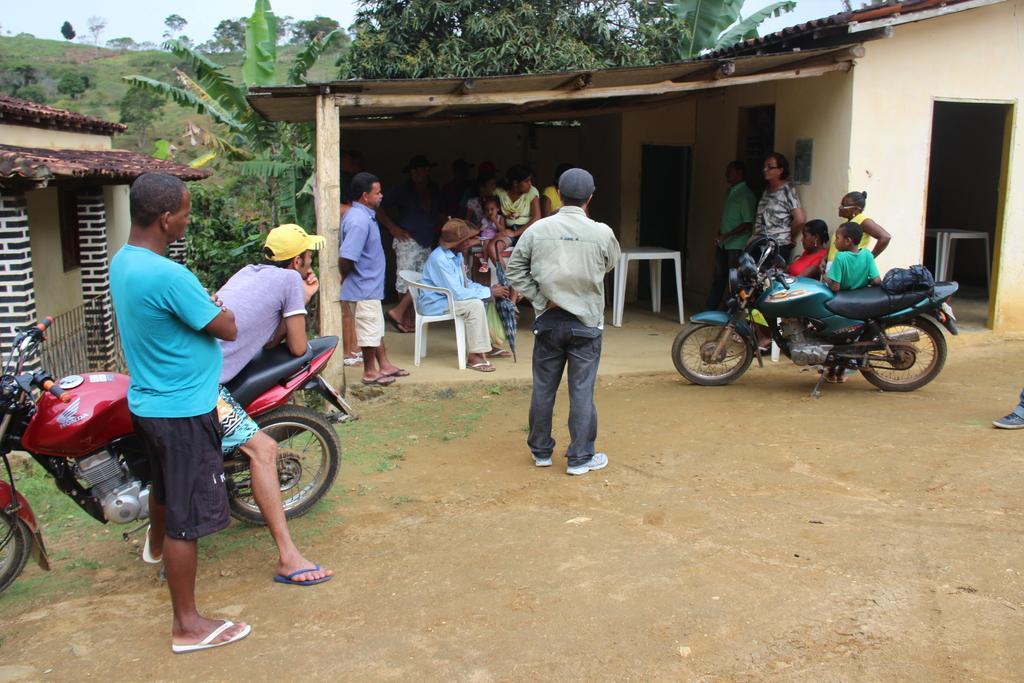Could you give a brief overview of what you see in this image? In this picture, we see many people standing and sitting. In this picture, we see two bikes on which man with violet t-shirt and yellow cap sat on it. Behind them, we see a house and behind that, we see trees. 